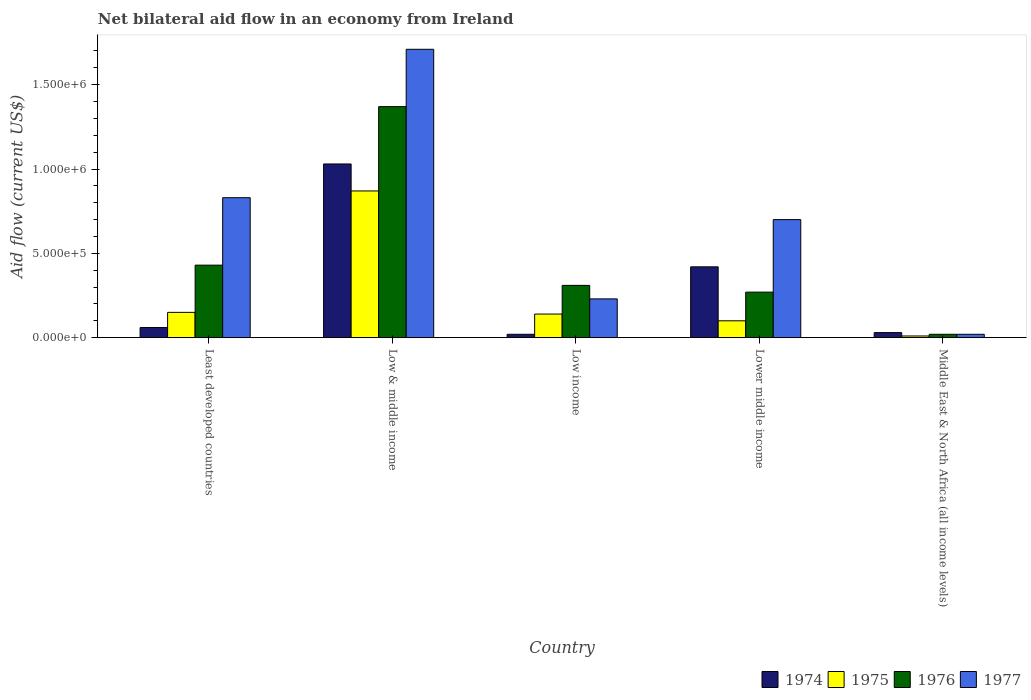How many groups of bars are there?
Provide a short and direct response. 5. Are the number of bars on each tick of the X-axis equal?
Ensure brevity in your answer.  Yes. How many bars are there on the 4th tick from the left?
Your answer should be very brief. 4. How many bars are there on the 4th tick from the right?
Provide a succinct answer. 4. What is the label of the 3rd group of bars from the left?
Make the answer very short. Low income. In how many cases, is the number of bars for a given country not equal to the number of legend labels?
Your answer should be compact. 0. Across all countries, what is the maximum net bilateral aid flow in 1974?
Keep it short and to the point. 1.03e+06. In which country was the net bilateral aid flow in 1975 maximum?
Provide a short and direct response. Low & middle income. In which country was the net bilateral aid flow in 1975 minimum?
Provide a succinct answer. Middle East & North Africa (all income levels). What is the total net bilateral aid flow in 1977 in the graph?
Your response must be concise. 3.49e+06. What is the average net bilateral aid flow in 1975 per country?
Ensure brevity in your answer.  2.54e+05. What is the ratio of the net bilateral aid flow in 1976 in Low & middle income to that in Middle East & North Africa (all income levels)?
Make the answer very short. 68.5. What is the difference between the highest and the second highest net bilateral aid flow in 1976?
Your answer should be compact. 9.40e+05. What is the difference between the highest and the lowest net bilateral aid flow in 1976?
Ensure brevity in your answer.  1.35e+06. What does the 3rd bar from the left in Least developed countries represents?
Your response must be concise. 1976. What does the 3rd bar from the right in Lower middle income represents?
Keep it short and to the point. 1975. Is it the case that in every country, the sum of the net bilateral aid flow in 1975 and net bilateral aid flow in 1976 is greater than the net bilateral aid flow in 1977?
Provide a short and direct response. No. How many bars are there?
Provide a short and direct response. 20. Are all the bars in the graph horizontal?
Ensure brevity in your answer.  No. Are the values on the major ticks of Y-axis written in scientific E-notation?
Provide a succinct answer. Yes. Does the graph contain grids?
Your answer should be compact. No. Where does the legend appear in the graph?
Make the answer very short. Bottom right. How many legend labels are there?
Provide a short and direct response. 4. What is the title of the graph?
Provide a succinct answer. Net bilateral aid flow in an economy from Ireland. What is the label or title of the X-axis?
Your answer should be very brief. Country. What is the label or title of the Y-axis?
Provide a short and direct response. Aid flow (current US$). What is the Aid flow (current US$) in 1975 in Least developed countries?
Provide a succinct answer. 1.50e+05. What is the Aid flow (current US$) of 1977 in Least developed countries?
Make the answer very short. 8.30e+05. What is the Aid flow (current US$) in 1974 in Low & middle income?
Ensure brevity in your answer.  1.03e+06. What is the Aid flow (current US$) of 1975 in Low & middle income?
Your answer should be very brief. 8.70e+05. What is the Aid flow (current US$) in 1976 in Low & middle income?
Offer a terse response. 1.37e+06. What is the Aid flow (current US$) of 1977 in Low & middle income?
Offer a terse response. 1.71e+06. What is the Aid flow (current US$) of 1975 in Low income?
Give a very brief answer. 1.40e+05. What is the Aid flow (current US$) of 1975 in Lower middle income?
Provide a short and direct response. 1.00e+05. What is the Aid flow (current US$) in 1976 in Lower middle income?
Give a very brief answer. 2.70e+05. What is the Aid flow (current US$) in 1977 in Lower middle income?
Your answer should be compact. 7.00e+05. What is the Aid flow (current US$) of 1974 in Middle East & North Africa (all income levels)?
Your answer should be very brief. 3.00e+04. What is the Aid flow (current US$) in 1976 in Middle East & North Africa (all income levels)?
Ensure brevity in your answer.  2.00e+04. Across all countries, what is the maximum Aid flow (current US$) in 1974?
Ensure brevity in your answer.  1.03e+06. Across all countries, what is the maximum Aid flow (current US$) of 1975?
Your answer should be compact. 8.70e+05. Across all countries, what is the maximum Aid flow (current US$) of 1976?
Provide a succinct answer. 1.37e+06. Across all countries, what is the maximum Aid flow (current US$) of 1977?
Ensure brevity in your answer.  1.71e+06. Across all countries, what is the minimum Aid flow (current US$) in 1974?
Give a very brief answer. 2.00e+04. Across all countries, what is the minimum Aid flow (current US$) in 1977?
Give a very brief answer. 2.00e+04. What is the total Aid flow (current US$) in 1974 in the graph?
Provide a short and direct response. 1.56e+06. What is the total Aid flow (current US$) in 1975 in the graph?
Give a very brief answer. 1.27e+06. What is the total Aid flow (current US$) in 1976 in the graph?
Offer a terse response. 2.40e+06. What is the total Aid flow (current US$) in 1977 in the graph?
Ensure brevity in your answer.  3.49e+06. What is the difference between the Aid flow (current US$) of 1974 in Least developed countries and that in Low & middle income?
Give a very brief answer. -9.70e+05. What is the difference between the Aid flow (current US$) of 1975 in Least developed countries and that in Low & middle income?
Your response must be concise. -7.20e+05. What is the difference between the Aid flow (current US$) of 1976 in Least developed countries and that in Low & middle income?
Your answer should be very brief. -9.40e+05. What is the difference between the Aid flow (current US$) in 1977 in Least developed countries and that in Low & middle income?
Ensure brevity in your answer.  -8.80e+05. What is the difference between the Aid flow (current US$) in 1974 in Least developed countries and that in Low income?
Make the answer very short. 4.00e+04. What is the difference between the Aid flow (current US$) in 1975 in Least developed countries and that in Low income?
Ensure brevity in your answer.  10000. What is the difference between the Aid flow (current US$) in 1976 in Least developed countries and that in Low income?
Offer a terse response. 1.20e+05. What is the difference between the Aid flow (current US$) in 1974 in Least developed countries and that in Lower middle income?
Make the answer very short. -3.60e+05. What is the difference between the Aid flow (current US$) in 1975 in Least developed countries and that in Lower middle income?
Ensure brevity in your answer.  5.00e+04. What is the difference between the Aid flow (current US$) of 1977 in Least developed countries and that in Lower middle income?
Your answer should be compact. 1.30e+05. What is the difference between the Aid flow (current US$) of 1976 in Least developed countries and that in Middle East & North Africa (all income levels)?
Provide a succinct answer. 4.10e+05. What is the difference between the Aid flow (current US$) in 1977 in Least developed countries and that in Middle East & North Africa (all income levels)?
Your answer should be very brief. 8.10e+05. What is the difference between the Aid flow (current US$) in 1974 in Low & middle income and that in Low income?
Make the answer very short. 1.01e+06. What is the difference between the Aid flow (current US$) of 1975 in Low & middle income and that in Low income?
Your answer should be very brief. 7.30e+05. What is the difference between the Aid flow (current US$) in 1976 in Low & middle income and that in Low income?
Ensure brevity in your answer.  1.06e+06. What is the difference between the Aid flow (current US$) in 1977 in Low & middle income and that in Low income?
Keep it short and to the point. 1.48e+06. What is the difference between the Aid flow (current US$) in 1974 in Low & middle income and that in Lower middle income?
Offer a terse response. 6.10e+05. What is the difference between the Aid flow (current US$) of 1975 in Low & middle income and that in Lower middle income?
Provide a short and direct response. 7.70e+05. What is the difference between the Aid flow (current US$) of 1976 in Low & middle income and that in Lower middle income?
Offer a very short reply. 1.10e+06. What is the difference between the Aid flow (current US$) of 1977 in Low & middle income and that in Lower middle income?
Keep it short and to the point. 1.01e+06. What is the difference between the Aid flow (current US$) of 1975 in Low & middle income and that in Middle East & North Africa (all income levels)?
Your answer should be very brief. 8.60e+05. What is the difference between the Aid flow (current US$) in 1976 in Low & middle income and that in Middle East & North Africa (all income levels)?
Provide a succinct answer. 1.35e+06. What is the difference between the Aid flow (current US$) of 1977 in Low & middle income and that in Middle East & North Africa (all income levels)?
Your answer should be very brief. 1.69e+06. What is the difference between the Aid flow (current US$) of 1974 in Low income and that in Lower middle income?
Offer a very short reply. -4.00e+05. What is the difference between the Aid flow (current US$) in 1976 in Low income and that in Lower middle income?
Give a very brief answer. 4.00e+04. What is the difference between the Aid flow (current US$) in 1977 in Low income and that in Lower middle income?
Provide a short and direct response. -4.70e+05. What is the difference between the Aid flow (current US$) in 1974 in Low income and that in Middle East & North Africa (all income levels)?
Provide a succinct answer. -10000. What is the difference between the Aid flow (current US$) in 1976 in Low income and that in Middle East & North Africa (all income levels)?
Your answer should be very brief. 2.90e+05. What is the difference between the Aid flow (current US$) in 1977 in Low income and that in Middle East & North Africa (all income levels)?
Your answer should be very brief. 2.10e+05. What is the difference between the Aid flow (current US$) in 1975 in Lower middle income and that in Middle East & North Africa (all income levels)?
Offer a very short reply. 9.00e+04. What is the difference between the Aid flow (current US$) in 1976 in Lower middle income and that in Middle East & North Africa (all income levels)?
Make the answer very short. 2.50e+05. What is the difference between the Aid flow (current US$) in 1977 in Lower middle income and that in Middle East & North Africa (all income levels)?
Your response must be concise. 6.80e+05. What is the difference between the Aid flow (current US$) of 1974 in Least developed countries and the Aid flow (current US$) of 1975 in Low & middle income?
Give a very brief answer. -8.10e+05. What is the difference between the Aid flow (current US$) of 1974 in Least developed countries and the Aid flow (current US$) of 1976 in Low & middle income?
Offer a very short reply. -1.31e+06. What is the difference between the Aid flow (current US$) of 1974 in Least developed countries and the Aid flow (current US$) of 1977 in Low & middle income?
Ensure brevity in your answer.  -1.65e+06. What is the difference between the Aid flow (current US$) in 1975 in Least developed countries and the Aid flow (current US$) in 1976 in Low & middle income?
Provide a succinct answer. -1.22e+06. What is the difference between the Aid flow (current US$) in 1975 in Least developed countries and the Aid flow (current US$) in 1977 in Low & middle income?
Offer a terse response. -1.56e+06. What is the difference between the Aid flow (current US$) in 1976 in Least developed countries and the Aid flow (current US$) in 1977 in Low & middle income?
Keep it short and to the point. -1.28e+06. What is the difference between the Aid flow (current US$) of 1974 in Least developed countries and the Aid flow (current US$) of 1975 in Low income?
Ensure brevity in your answer.  -8.00e+04. What is the difference between the Aid flow (current US$) in 1974 in Least developed countries and the Aid flow (current US$) in 1976 in Low income?
Provide a short and direct response. -2.50e+05. What is the difference between the Aid flow (current US$) of 1974 in Least developed countries and the Aid flow (current US$) of 1977 in Low income?
Offer a terse response. -1.70e+05. What is the difference between the Aid flow (current US$) in 1975 in Least developed countries and the Aid flow (current US$) in 1977 in Low income?
Provide a succinct answer. -8.00e+04. What is the difference between the Aid flow (current US$) in 1976 in Least developed countries and the Aid flow (current US$) in 1977 in Low income?
Ensure brevity in your answer.  2.00e+05. What is the difference between the Aid flow (current US$) in 1974 in Least developed countries and the Aid flow (current US$) in 1975 in Lower middle income?
Offer a very short reply. -4.00e+04. What is the difference between the Aid flow (current US$) in 1974 in Least developed countries and the Aid flow (current US$) in 1976 in Lower middle income?
Ensure brevity in your answer.  -2.10e+05. What is the difference between the Aid flow (current US$) in 1974 in Least developed countries and the Aid flow (current US$) in 1977 in Lower middle income?
Make the answer very short. -6.40e+05. What is the difference between the Aid flow (current US$) in 1975 in Least developed countries and the Aid flow (current US$) in 1976 in Lower middle income?
Provide a succinct answer. -1.20e+05. What is the difference between the Aid flow (current US$) in 1975 in Least developed countries and the Aid flow (current US$) in 1977 in Lower middle income?
Give a very brief answer. -5.50e+05. What is the difference between the Aid flow (current US$) in 1974 in Least developed countries and the Aid flow (current US$) in 1975 in Middle East & North Africa (all income levels)?
Provide a succinct answer. 5.00e+04. What is the difference between the Aid flow (current US$) of 1974 in Least developed countries and the Aid flow (current US$) of 1976 in Middle East & North Africa (all income levels)?
Provide a succinct answer. 4.00e+04. What is the difference between the Aid flow (current US$) of 1975 in Least developed countries and the Aid flow (current US$) of 1976 in Middle East & North Africa (all income levels)?
Provide a succinct answer. 1.30e+05. What is the difference between the Aid flow (current US$) in 1974 in Low & middle income and the Aid flow (current US$) in 1975 in Low income?
Keep it short and to the point. 8.90e+05. What is the difference between the Aid flow (current US$) of 1974 in Low & middle income and the Aid flow (current US$) of 1976 in Low income?
Keep it short and to the point. 7.20e+05. What is the difference between the Aid flow (current US$) in 1975 in Low & middle income and the Aid flow (current US$) in 1976 in Low income?
Keep it short and to the point. 5.60e+05. What is the difference between the Aid flow (current US$) in 1975 in Low & middle income and the Aid flow (current US$) in 1977 in Low income?
Keep it short and to the point. 6.40e+05. What is the difference between the Aid flow (current US$) in 1976 in Low & middle income and the Aid flow (current US$) in 1977 in Low income?
Give a very brief answer. 1.14e+06. What is the difference between the Aid flow (current US$) of 1974 in Low & middle income and the Aid flow (current US$) of 1975 in Lower middle income?
Your answer should be compact. 9.30e+05. What is the difference between the Aid flow (current US$) in 1974 in Low & middle income and the Aid flow (current US$) in 1976 in Lower middle income?
Your response must be concise. 7.60e+05. What is the difference between the Aid flow (current US$) of 1975 in Low & middle income and the Aid flow (current US$) of 1976 in Lower middle income?
Ensure brevity in your answer.  6.00e+05. What is the difference between the Aid flow (current US$) in 1975 in Low & middle income and the Aid flow (current US$) in 1977 in Lower middle income?
Provide a short and direct response. 1.70e+05. What is the difference between the Aid flow (current US$) in 1976 in Low & middle income and the Aid flow (current US$) in 1977 in Lower middle income?
Offer a terse response. 6.70e+05. What is the difference between the Aid flow (current US$) in 1974 in Low & middle income and the Aid flow (current US$) in 1975 in Middle East & North Africa (all income levels)?
Provide a short and direct response. 1.02e+06. What is the difference between the Aid flow (current US$) of 1974 in Low & middle income and the Aid flow (current US$) of 1976 in Middle East & North Africa (all income levels)?
Make the answer very short. 1.01e+06. What is the difference between the Aid flow (current US$) of 1974 in Low & middle income and the Aid flow (current US$) of 1977 in Middle East & North Africa (all income levels)?
Give a very brief answer. 1.01e+06. What is the difference between the Aid flow (current US$) in 1975 in Low & middle income and the Aid flow (current US$) in 1976 in Middle East & North Africa (all income levels)?
Offer a terse response. 8.50e+05. What is the difference between the Aid flow (current US$) of 1975 in Low & middle income and the Aid flow (current US$) of 1977 in Middle East & North Africa (all income levels)?
Your answer should be very brief. 8.50e+05. What is the difference between the Aid flow (current US$) in 1976 in Low & middle income and the Aid flow (current US$) in 1977 in Middle East & North Africa (all income levels)?
Your answer should be very brief. 1.35e+06. What is the difference between the Aid flow (current US$) in 1974 in Low income and the Aid flow (current US$) in 1975 in Lower middle income?
Give a very brief answer. -8.00e+04. What is the difference between the Aid flow (current US$) in 1974 in Low income and the Aid flow (current US$) in 1976 in Lower middle income?
Keep it short and to the point. -2.50e+05. What is the difference between the Aid flow (current US$) of 1974 in Low income and the Aid flow (current US$) of 1977 in Lower middle income?
Make the answer very short. -6.80e+05. What is the difference between the Aid flow (current US$) of 1975 in Low income and the Aid flow (current US$) of 1977 in Lower middle income?
Provide a short and direct response. -5.60e+05. What is the difference between the Aid flow (current US$) of 1976 in Low income and the Aid flow (current US$) of 1977 in Lower middle income?
Your response must be concise. -3.90e+05. What is the difference between the Aid flow (current US$) in 1974 in Low income and the Aid flow (current US$) in 1975 in Middle East & North Africa (all income levels)?
Your response must be concise. 10000. What is the difference between the Aid flow (current US$) in 1974 in Low income and the Aid flow (current US$) in 1977 in Middle East & North Africa (all income levels)?
Offer a terse response. 0. What is the difference between the Aid flow (current US$) of 1975 in Low income and the Aid flow (current US$) of 1976 in Middle East & North Africa (all income levels)?
Your response must be concise. 1.20e+05. What is the difference between the Aid flow (current US$) of 1974 in Lower middle income and the Aid flow (current US$) of 1976 in Middle East & North Africa (all income levels)?
Provide a short and direct response. 4.00e+05. What is the difference between the Aid flow (current US$) of 1974 in Lower middle income and the Aid flow (current US$) of 1977 in Middle East & North Africa (all income levels)?
Your answer should be compact. 4.00e+05. What is the average Aid flow (current US$) of 1974 per country?
Make the answer very short. 3.12e+05. What is the average Aid flow (current US$) of 1975 per country?
Offer a very short reply. 2.54e+05. What is the average Aid flow (current US$) of 1976 per country?
Offer a very short reply. 4.80e+05. What is the average Aid flow (current US$) in 1977 per country?
Ensure brevity in your answer.  6.98e+05. What is the difference between the Aid flow (current US$) of 1974 and Aid flow (current US$) of 1976 in Least developed countries?
Provide a short and direct response. -3.70e+05. What is the difference between the Aid flow (current US$) in 1974 and Aid flow (current US$) in 1977 in Least developed countries?
Ensure brevity in your answer.  -7.70e+05. What is the difference between the Aid flow (current US$) in 1975 and Aid flow (current US$) in 1976 in Least developed countries?
Provide a short and direct response. -2.80e+05. What is the difference between the Aid flow (current US$) of 1975 and Aid flow (current US$) of 1977 in Least developed countries?
Your answer should be very brief. -6.80e+05. What is the difference between the Aid flow (current US$) in 1976 and Aid flow (current US$) in 1977 in Least developed countries?
Make the answer very short. -4.00e+05. What is the difference between the Aid flow (current US$) in 1974 and Aid flow (current US$) in 1977 in Low & middle income?
Provide a short and direct response. -6.80e+05. What is the difference between the Aid flow (current US$) in 1975 and Aid flow (current US$) in 1976 in Low & middle income?
Provide a short and direct response. -5.00e+05. What is the difference between the Aid flow (current US$) of 1975 and Aid flow (current US$) of 1977 in Low & middle income?
Your answer should be compact. -8.40e+05. What is the difference between the Aid flow (current US$) of 1974 and Aid flow (current US$) of 1975 in Low income?
Ensure brevity in your answer.  -1.20e+05. What is the difference between the Aid flow (current US$) in 1975 and Aid flow (current US$) in 1976 in Low income?
Ensure brevity in your answer.  -1.70e+05. What is the difference between the Aid flow (current US$) in 1974 and Aid flow (current US$) in 1975 in Lower middle income?
Your answer should be very brief. 3.20e+05. What is the difference between the Aid flow (current US$) in 1974 and Aid flow (current US$) in 1977 in Lower middle income?
Keep it short and to the point. -2.80e+05. What is the difference between the Aid flow (current US$) of 1975 and Aid flow (current US$) of 1976 in Lower middle income?
Offer a terse response. -1.70e+05. What is the difference between the Aid flow (current US$) of 1975 and Aid flow (current US$) of 1977 in Lower middle income?
Provide a short and direct response. -6.00e+05. What is the difference between the Aid flow (current US$) of 1976 and Aid flow (current US$) of 1977 in Lower middle income?
Provide a succinct answer. -4.30e+05. What is the difference between the Aid flow (current US$) of 1975 and Aid flow (current US$) of 1976 in Middle East & North Africa (all income levels)?
Make the answer very short. -10000. What is the difference between the Aid flow (current US$) of 1975 and Aid flow (current US$) of 1977 in Middle East & North Africa (all income levels)?
Your response must be concise. -10000. What is the ratio of the Aid flow (current US$) in 1974 in Least developed countries to that in Low & middle income?
Your answer should be compact. 0.06. What is the ratio of the Aid flow (current US$) in 1975 in Least developed countries to that in Low & middle income?
Ensure brevity in your answer.  0.17. What is the ratio of the Aid flow (current US$) in 1976 in Least developed countries to that in Low & middle income?
Keep it short and to the point. 0.31. What is the ratio of the Aid flow (current US$) of 1977 in Least developed countries to that in Low & middle income?
Your answer should be very brief. 0.49. What is the ratio of the Aid flow (current US$) in 1975 in Least developed countries to that in Low income?
Give a very brief answer. 1.07. What is the ratio of the Aid flow (current US$) of 1976 in Least developed countries to that in Low income?
Your answer should be compact. 1.39. What is the ratio of the Aid flow (current US$) in 1977 in Least developed countries to that in Low income?
Offer a very short reply. 3.61. What is the ratio of the Aid flow (current US$) of 1974 in Least developed countries to that in Lower middle income?
Make the answer very short. 0.14. What is the ratio of the Aid flow (current US$) in 1975 in Least developed countries to that in Lower middle income?
Your response must be concise. 1.5. What is the ratio of the Aid flow (current US$) in 1976 in Least developed countries to that in Lower middle income?
Your answer should be compact. 1.59. What is the ratio of the Aid flow (current US$) of 1977 in Least developed countries to that in Lower middle income?
Keep it short and to the point. 1.19. What is the ratio of the Aid flow (current US$) in 1974 in Least developed countries to that in Middle East & North Africa (all income levels)?
Provide a succinct answer. 2. What is the ratio of the Aid flow (current US$) in 1976 in Least developed countries to that in Middle East & North Africa (all income levels)?
Keep it short and to the point. 21.5. What is the ratio of the Aid flow (current US$) in 1977 in Least developed countries to that in Middle East & North Africa (all income levels)?
Your answer should be very brief. 41.5. What is the ratio of the Aid flow (current US$) in 1974 in Low & middle income to that in Low income?
Offer a terse response. 51.5. What is the ratio of the Aid flow (current US$) in 1975 in Low & middle income to that in Low income?
Keep it short and to the point. 6.21. What is the ratio of the Aid flow (current US$) of 1976 in Low & middle income to that in Low income?
Give a very brief answer. 4.42. What is the ratio of the Aid flow (current US$) of 1977 in Low & middle income to that in Low income?
Offer a terse response. 7.43. What is the ratio of the Aid flow (current US$) of 1974 in Low & middle income to that in Lower middle income?
Make the answer very short. 2.45. What is the ratio of the Aid flow (current US$) of 1975 in Low & middle income to that in Lower middle income?
Provide a short and direct response. 8.7. What is the ratio of the Aid flow (current US$) of 1976 in Low & middle income to that in Lower middle income?
Make the answer very short. 5.07. What is the ratio of the Aid flow (current US$) of 1977 in Low & middle income to that in Lower middle income?
Keep it short and to the point. 2.44. What is the ratio of the Aid flow (current US$) of 1974 in Low & middle income to that in Middle East & North Africa (all income levels)?
Provide a short and direct response. 34.33. What is the ratio of the Aid flow (current US$) in 1976 in Low & middle income to that in Middle East & North Africa (all income levels)?
Provide a short and direct response. 68.5. What is the ratio of the Aid flow (current US$) of 1977 in Low & middle income to that in Middle East & North Africa (all income levels)?
Your response must be concise. 85.5. What is the ratio of the Aid flow (current US$) of 1974 in Low income to that in Lower middle income?
Ensure brevity in your answer.  0.05. What is the ratio of the Aid flow (current US$) of 1976 in Low income to that in Lower middle income?
Keep it short and to the point. 1.15. What is the ratio of the Aid flow (current US$) of 1977 in Low income to that in Lower middle income?
Provide a succinct answer. 0.33. What is the ratio of the Aid flow (current US$) in 1974 in Low income to that in Middle East & North Africa (all income levels)?
Your answer should be very brief. 0.67. What is the ratio of the Aid flow (current US$) in 1975 in Low income to that in Middle East & North Africa (all income levels)?
Keep it short and to the point. 14. What is the ratio of the Aid flow (current US$) in 1976 in Low income to that in Middle East & North Africa (all income levels)?
Keep it short and to the point. 15.5. What is the ratio of the Aid flow (current US$) of 1977 in Low income to that in Middle East & North Africa (all income levels)?
Ensure brevity in your answer.  11.5. What is the ratio of the Aid flow (current US$) of 1974 in Lower middle income to that in Middle East & North Africa (all income levels)?
Your answer should be very brief. 14. What is the ratio of the Aid flow (current US$) in 1975 in Lower middle income to that in Middle East & North Africa (all income levels)?
Offer a terse response. 10. What is the ratio of the Aid flow (current US$) in 1977 in Lower middle income to that in Middle East & North Africa (all income levels)?
Your answer should be very brief. 35. What is the difference between the highest and the second highest Aid flow (current US$) in 1974?
Offer a terse response. 6.10e+05. What is the difference between the highest and the second highest Aid flow (current US$) of 1975?
Your response must be concise. 7.20e+05. What is the difference between the highest and the second highest Aid flow (current US$) of 1976?
Give a very brief answer. 9.40e+05. What is the difference between the highest and the second highest Aid flow (current US$) of 1977?
Offer a very short reply. 8.80e+05. What is the difference between the highest and the lowest Aid flow (current US$) in 1974?
Provide a succinct answer. 1.01e+06. What is the difference between the highest and the lowest Aid flow (current US$) in 1975?
Your response must be concise. 8.60e+05. What is the difference between the highest and the lowest Aid flow (current US$) of 1976?
Make the answer very short. 1.35e+06. What is the difference between the highest and the lowest Aid flow (current US$) in 1977?
Offer a terse response. 1.69e+06. 